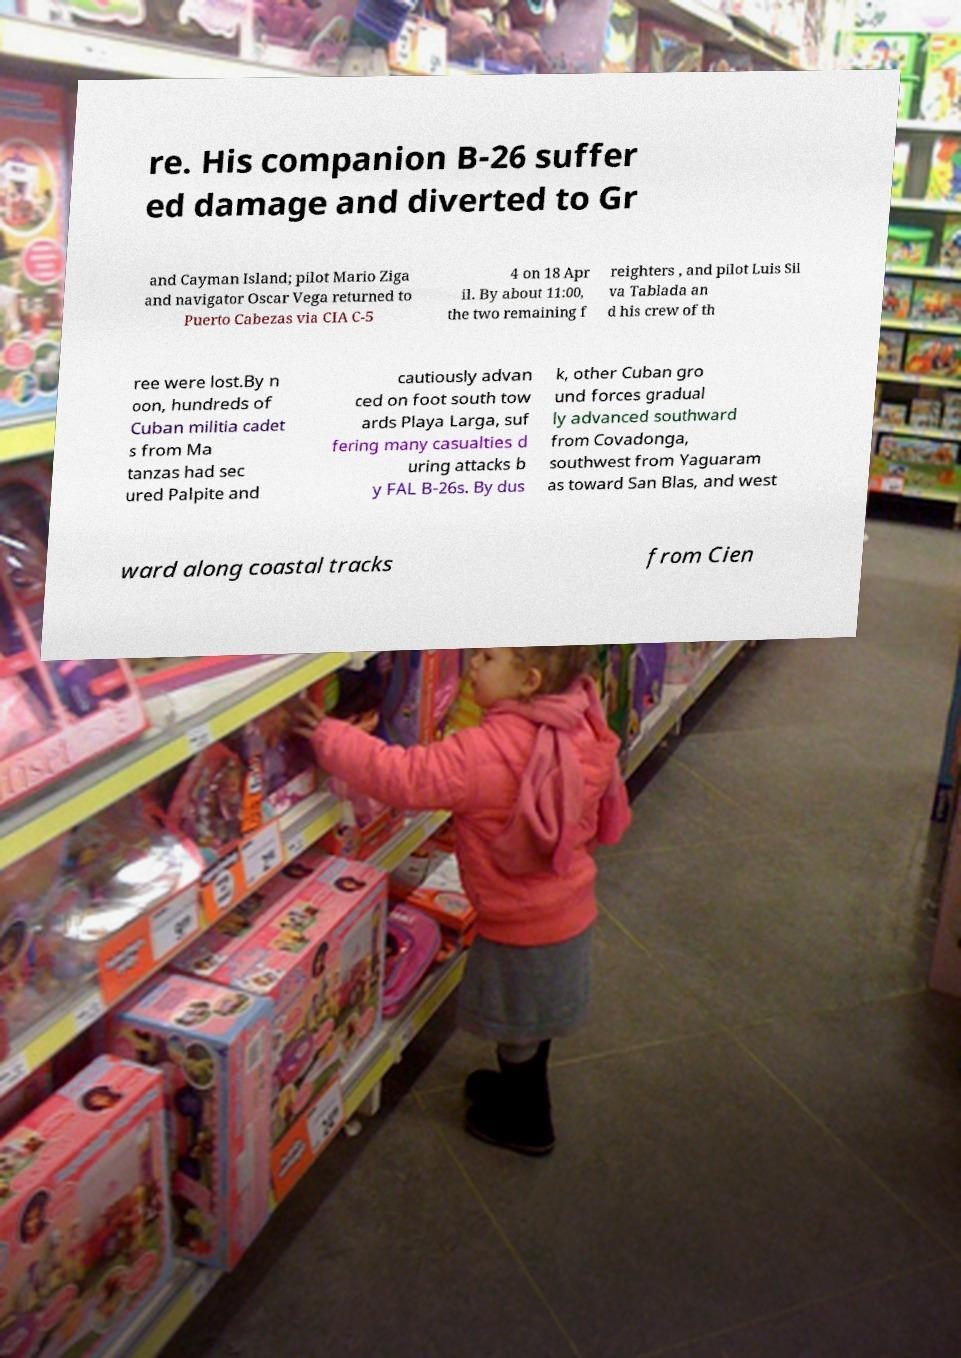Can you accurately transcribe the text from the provided image for me? re. His companion B-26 suffer ed damage and diverted to Gr and Cayman Island; pilot Mario Ziga and navigator Oscar Vega returned to Puerto Cabezas via CIA C-5 4 on 18 Apr il. By about 11:00, the two remaining f reighters , and pilot Luis Sil va Tablada an d his crew of th ree were lost.By n oon, hundreds of Cuban militia cadet s from Ma tanzas had sec ured Palpite and cautiously advan ced on foot south tow ards Playa Larga, suf fering many casualties d uring attacks b y FAL B-26s. By dus k, other Cuban gro und forces gradual ly advanced southward from Covadonga, southwest from Yaguaram as toward San Blas, and west ward along coastal tracks from Cien 